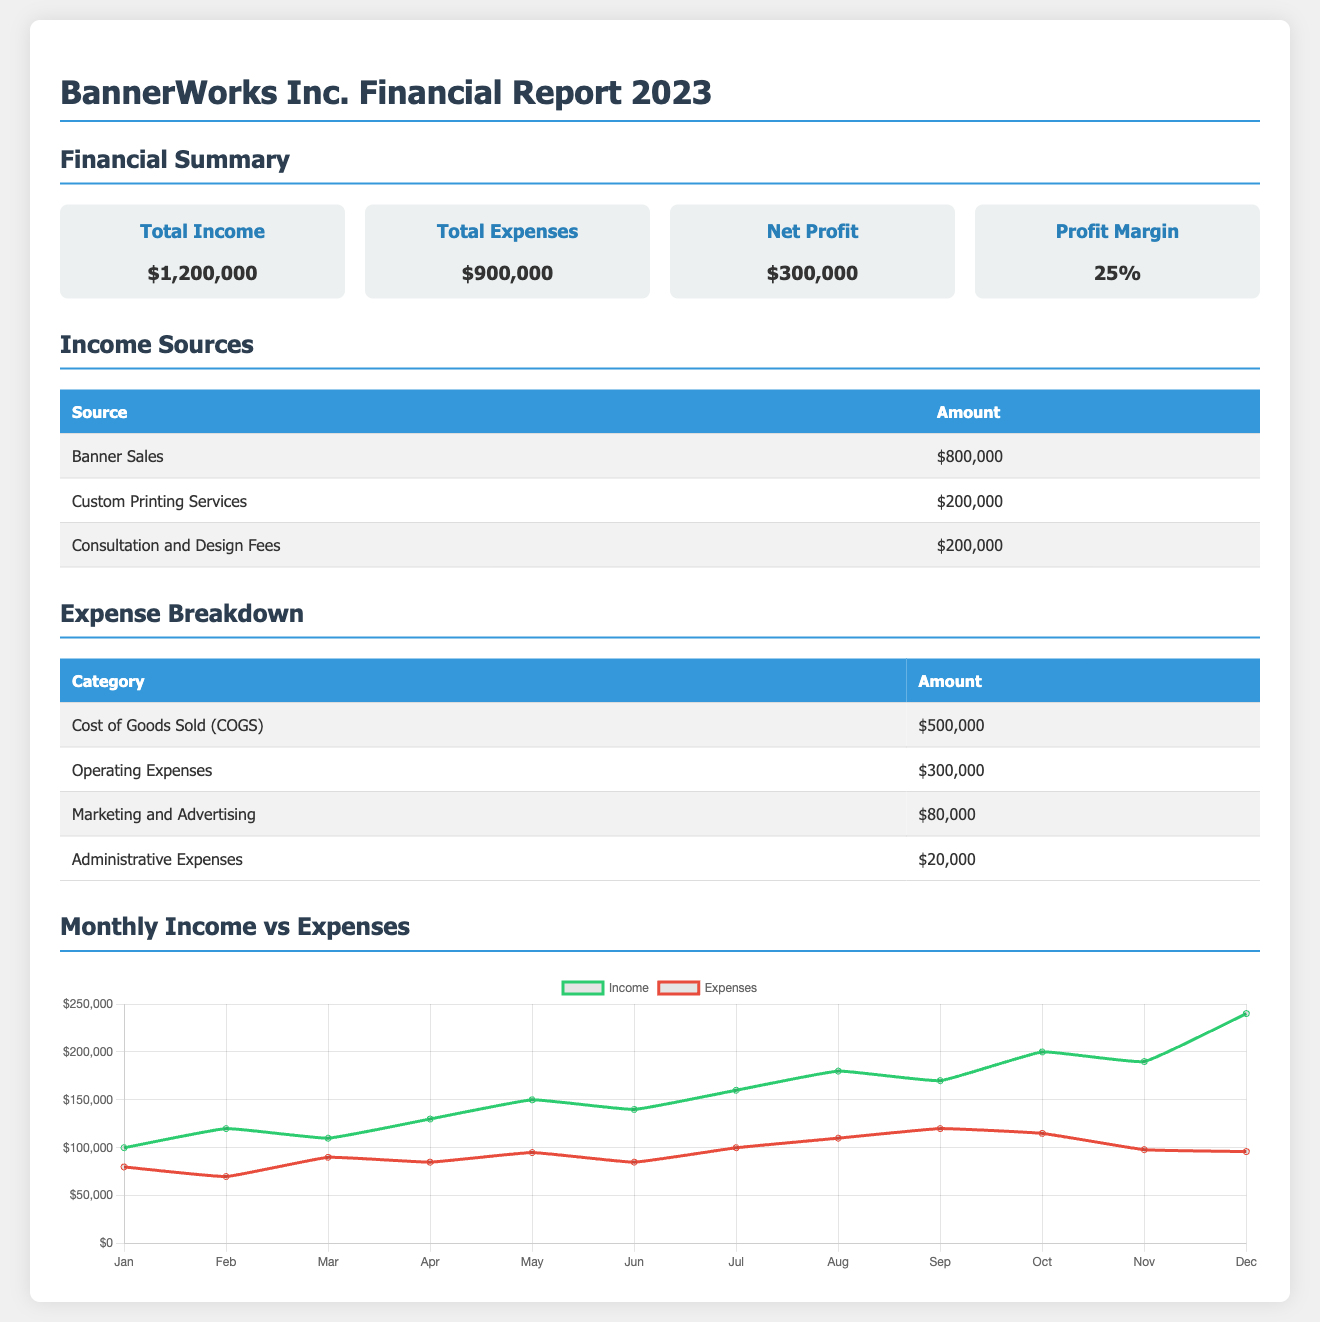What is the total income? The total income is shown in the financial summary as $1,200,000.
Answer: $1,200,000 What is the net profit? The net profit is calculated in the summary section and is indicated as $300,000.
Answer: $300,000 What are the operating expenses? Operating expenses are listed in the expense breakdown section as $300,000.
Answer: $300,000 Which source had the highest income? The income source with the highest amount is Banner Sales, which is $800,000 according to the income sources table.
Answer: Banner Sales What is the profit margin? The profit margin is stated in the financial summary as 25%.
Answer: 25% What was the income in December? The income for the month of December is represented in the chart as $240,000.
Answer: $240,000 Which month had the highest expenses? By evaluating the expense data over the year, the month with the highest expenses was August, as shown in the chart.
Answer: August What is the total amount for marketing and advertising? Marketing and advertising expenses total $80,000 as per the expense breakdown table.
Answer: $80,000 How many income sources are listed? There are three listed income sources in the income sources table.
Answer: Three 